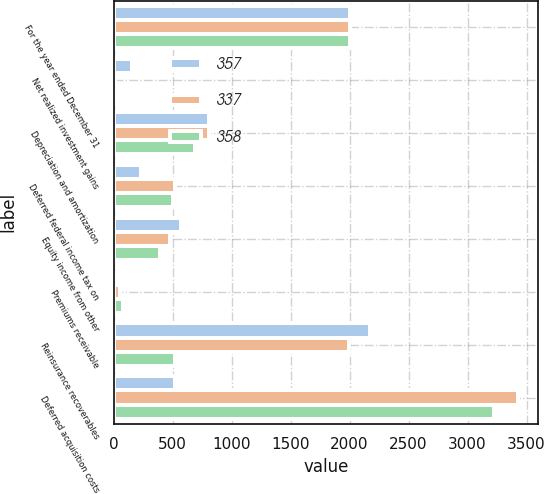<chart> <loc_0><loc_0><loc_500><loc_500><stacked_bar_chart><ecel><fcel>For the year ended December 31<fcel>Net realized investment gains<fcel>Depreciation and amortization<fcel>Deferred federal income tax on<fcel>Equity income from other<fcel>Premiums receivable<fcel>Reinsurance recoverables<fcel>Deferred acquisition costs<nl><fcel>357<fcel>2007<fcel>154<fcel>811<fcel>230<fcel>570<fcel>4<fcel>2172<fcel>521<nl><fcel>337<fcel>2006<fcel>11<fcel>808<fcel>521<fcel>478<fcel>57<fcel>1998<fcel>3427<nl><fcel>358<fcel>2005<fcel>17<fcel>691<fcel>500<fcel>395<fcel>77<fcel>520<fcel>3220<nl></chart> 